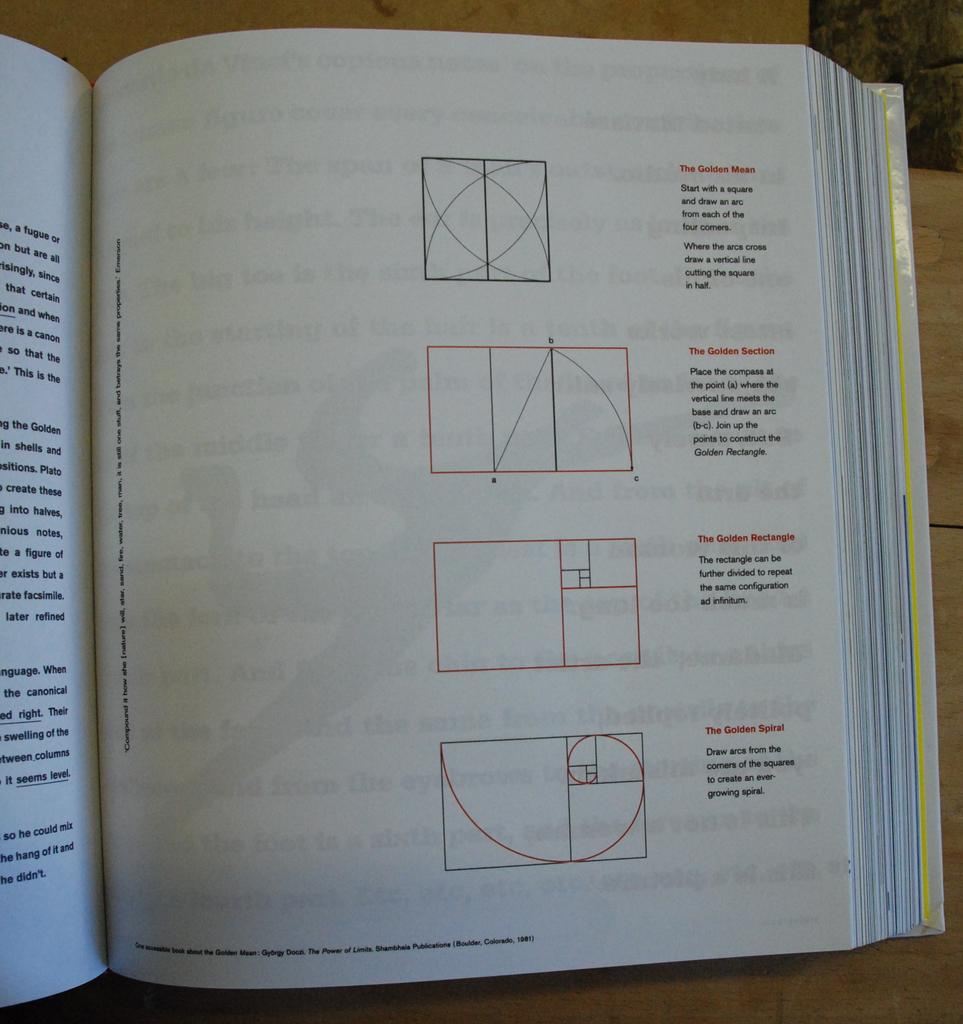Provide a one-sentence caption for the provided image. A math book opened to the description of The Golden Mean. 